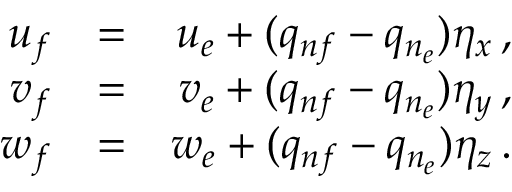<formula> <loc_0><loc_0><loc_500><loc_500>\begin{array} { r l r } { u _ { f } } & { = } & { u _ { e } + ( q _ { n f } - q _ { n _ { e } } ) \eta _ { x } \, , } \\ { v _ { f } } & { = } & { v _ { e } + ( q _ { n f } - q _ { n _ { e } } ) \eta _ { y } \, , } \\ { w _ { f } } & { = } & { w _ { e } + ( q _ { n f } - q _ { n _ { e } } ) \eta _ { z } \, . } \end{array}</formula> 